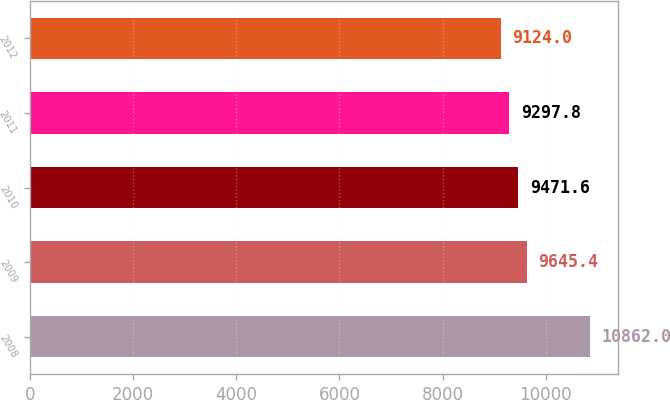<chart> <loc_0><loc_0><loc_500><loc_500><bar_chart><fcel>2008<fcel>2009<fcel>2010<fcel>2011<fcel>2012<nl><fcel>10862<fcel>9645.4<fcel>9471.6<fcel>9297.8<fcel>9124<nl></chart> 